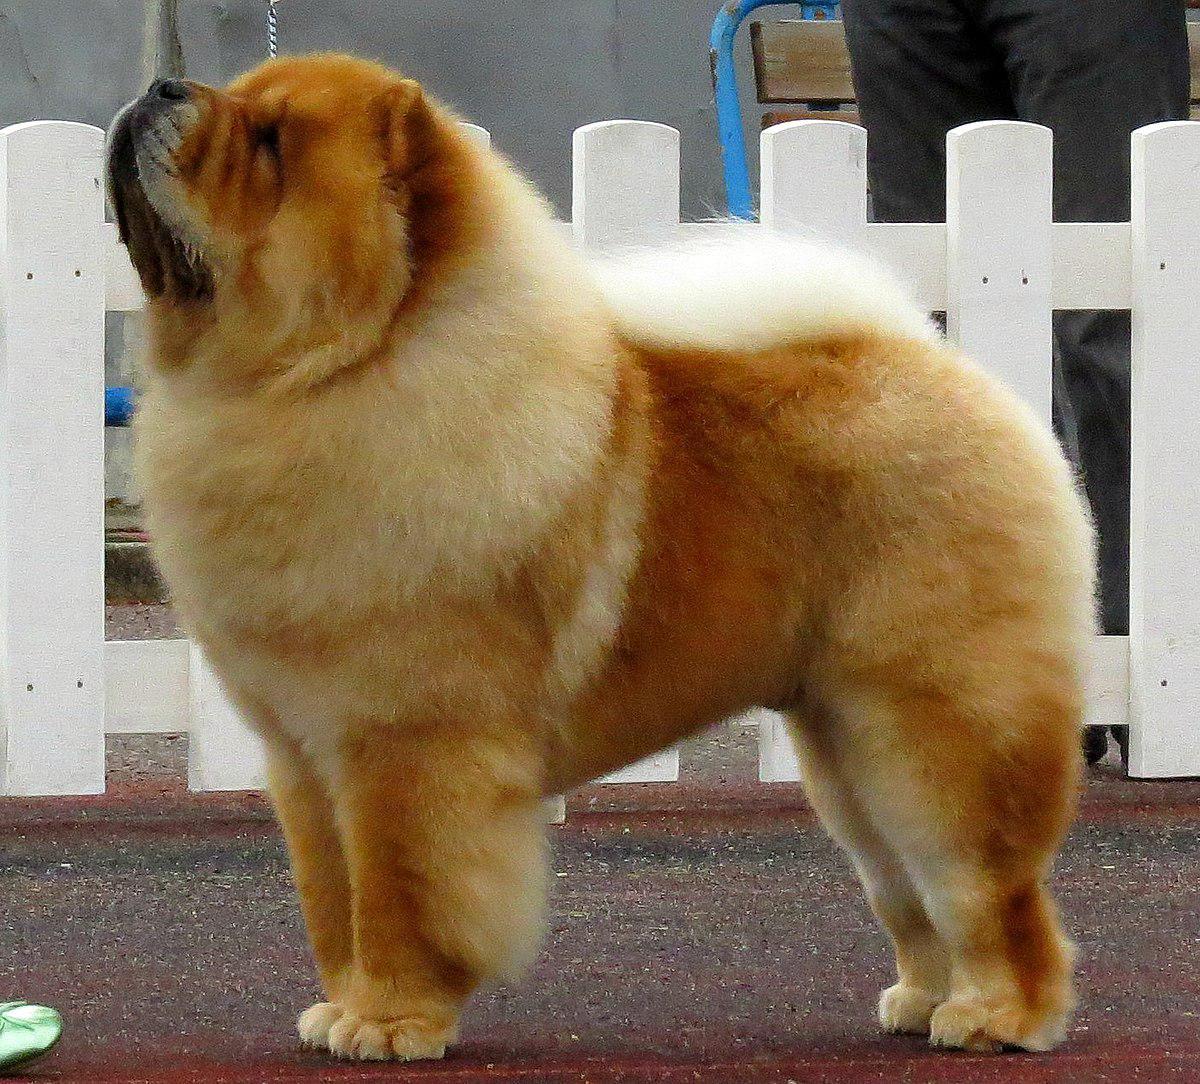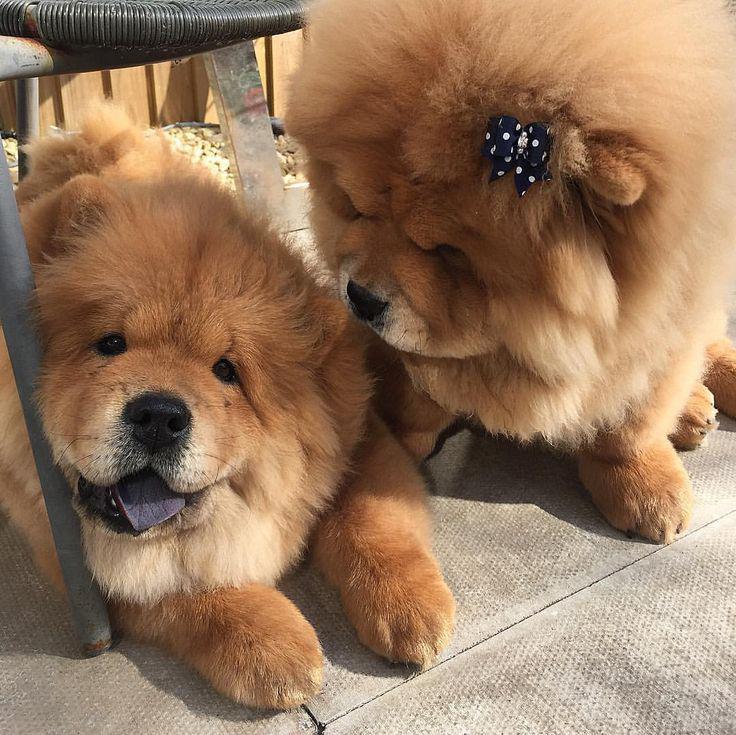The first image is the image on the left, the second image is the image on the right. Assess this claim about the two images: "One image features a chow standing on a red brick-colored surface and looking upward.". Correct or not? Answer yes or no. Yes. The first image is the image on the left, the second image is the image on the right. Assess this claim about the two images: "A single dog is lying down in the image on the right.". Correct or not? Answer yes or no. No. 